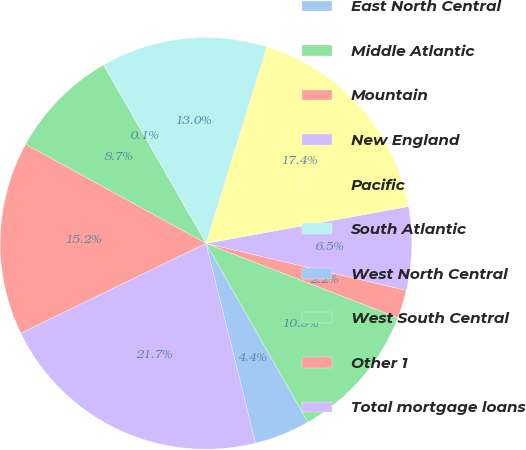<chart> <loc_0><loc_0><loc_500><loc_500><pie_chart><fcel>East North Central<fcel>Middle Atlantic<fcel>Mountain<fcel>New England<fcel>Pacific<fcel>South Atlantic<fcel>West North Central<fcel>West South Central<fcel>Other 1<fcel>Total mortgage loans<nl><fcel>4.38%<fcel>10.87%<fcel>2.21%<fcel>6.54%<fcel>17.35%<fcel>13.03%<fcel>0.05%<fcel>8.7%<fcel>15.19%<fcel>21.68%<nl></chart> 